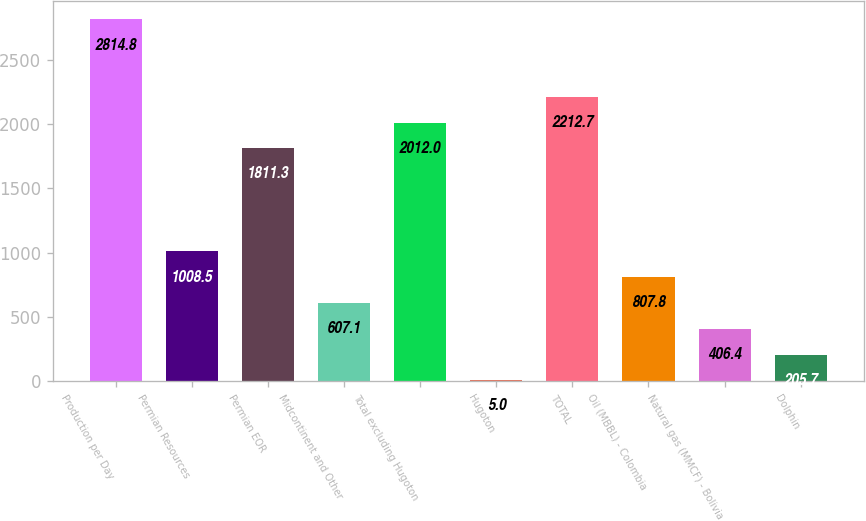Convert chart. <chart><loc_0><loc_0><loc_500><loc_500><bar_chart><fcel>Production per Day<fcel>Permian Resources<fcel>Permian EOR<fcel>Midcontinent and Other<fcel>Total excluding Hugoton<fcel>Hugoton<fcel>TOTAL<fcel>Oil (MBBL) - Colombia<fcel>Natural gas (MMCF) - Bolivia<fcel>Dolphin<nl><fcel>2814.8<fcel>1008.5<fcel>1811.3<fcel>607.1<fcel>2012<fcel>5<fcel>2212.7<fcel>807.8<fcel>406.4<fcel>205.7<nl></chart> 